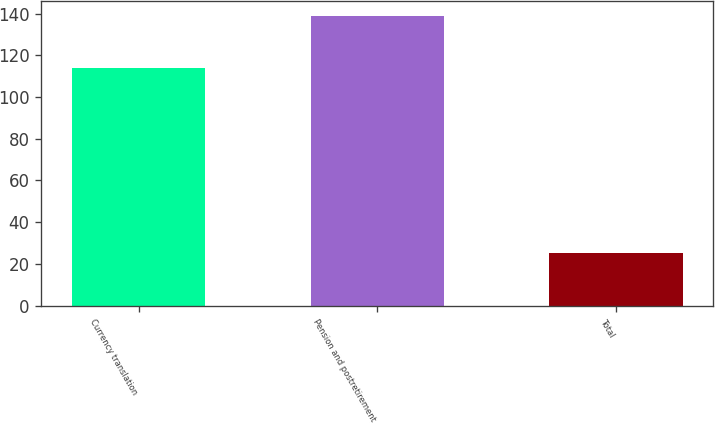Convert chart. <chart><loc_0><loc_0><loc_500><loc_500><bar_chart><fcel>Currency translation<fcel>Pension and postretirement<fcel>Total<nl><fcel>114<fcel>139<fcel>25<nl></chart> 